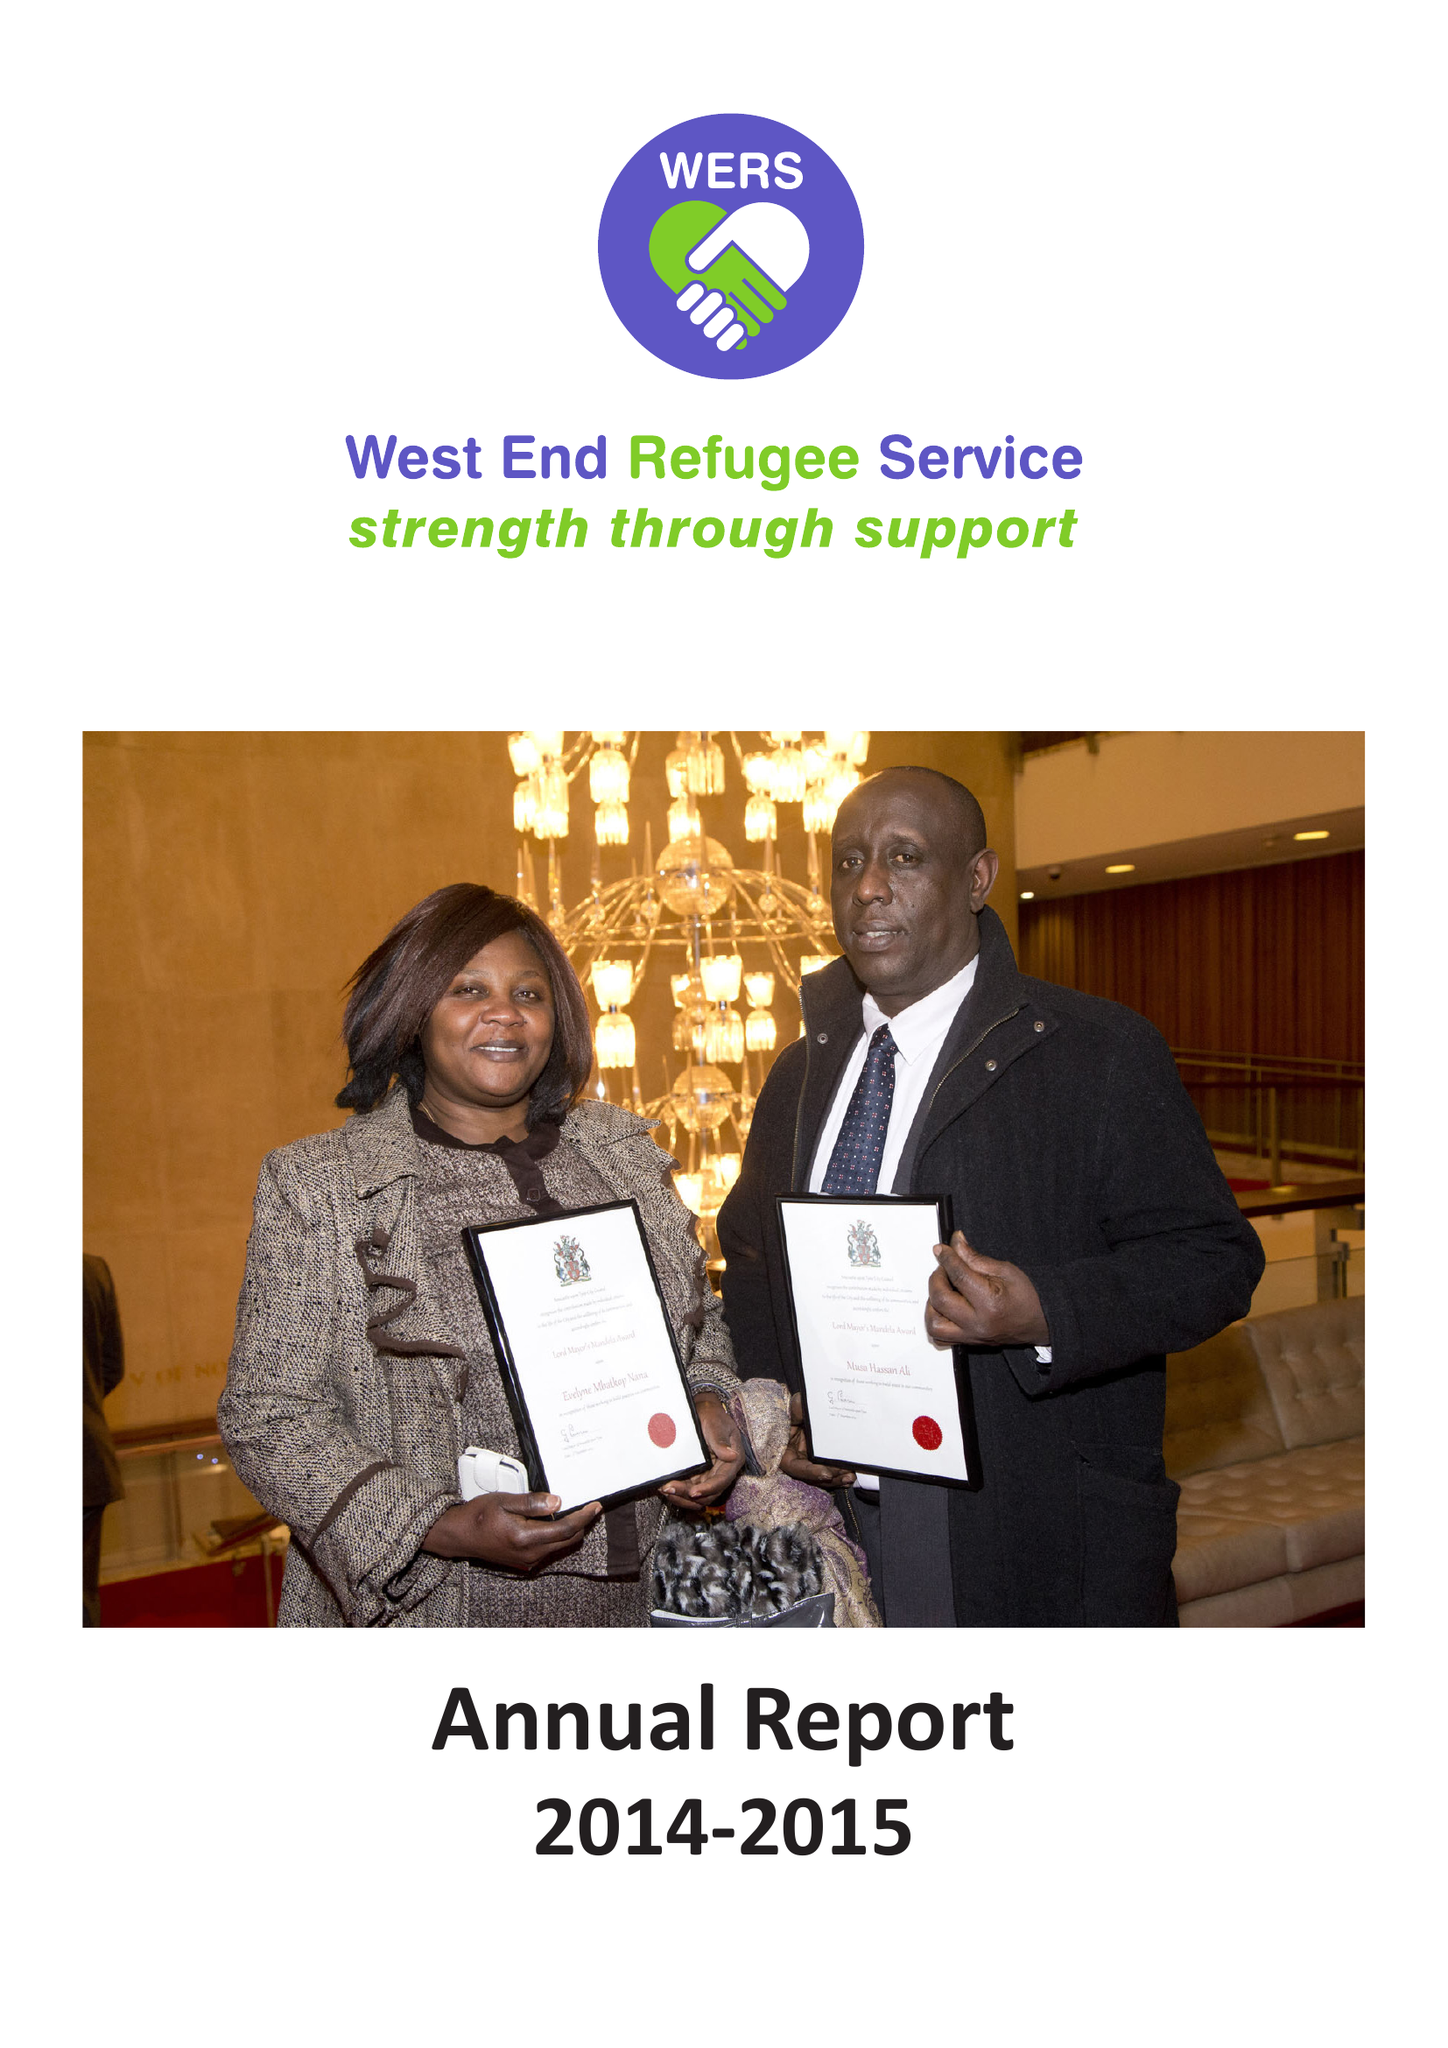What is the value for the address__postcode?
Answer the question using a single word or phrase. NE4 5JE 